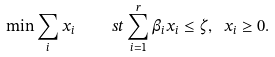Convert formula to latex. <formula><loc_0><loc_0><loc_500><loc_500>\min \sum _ { i } x _ { i } \quad s t \sum _ { i = 1 } ^ { r } \beta _ { i } x _ { i } \leq \zeta , \ x _ { i } \geq 0 .</formula> 